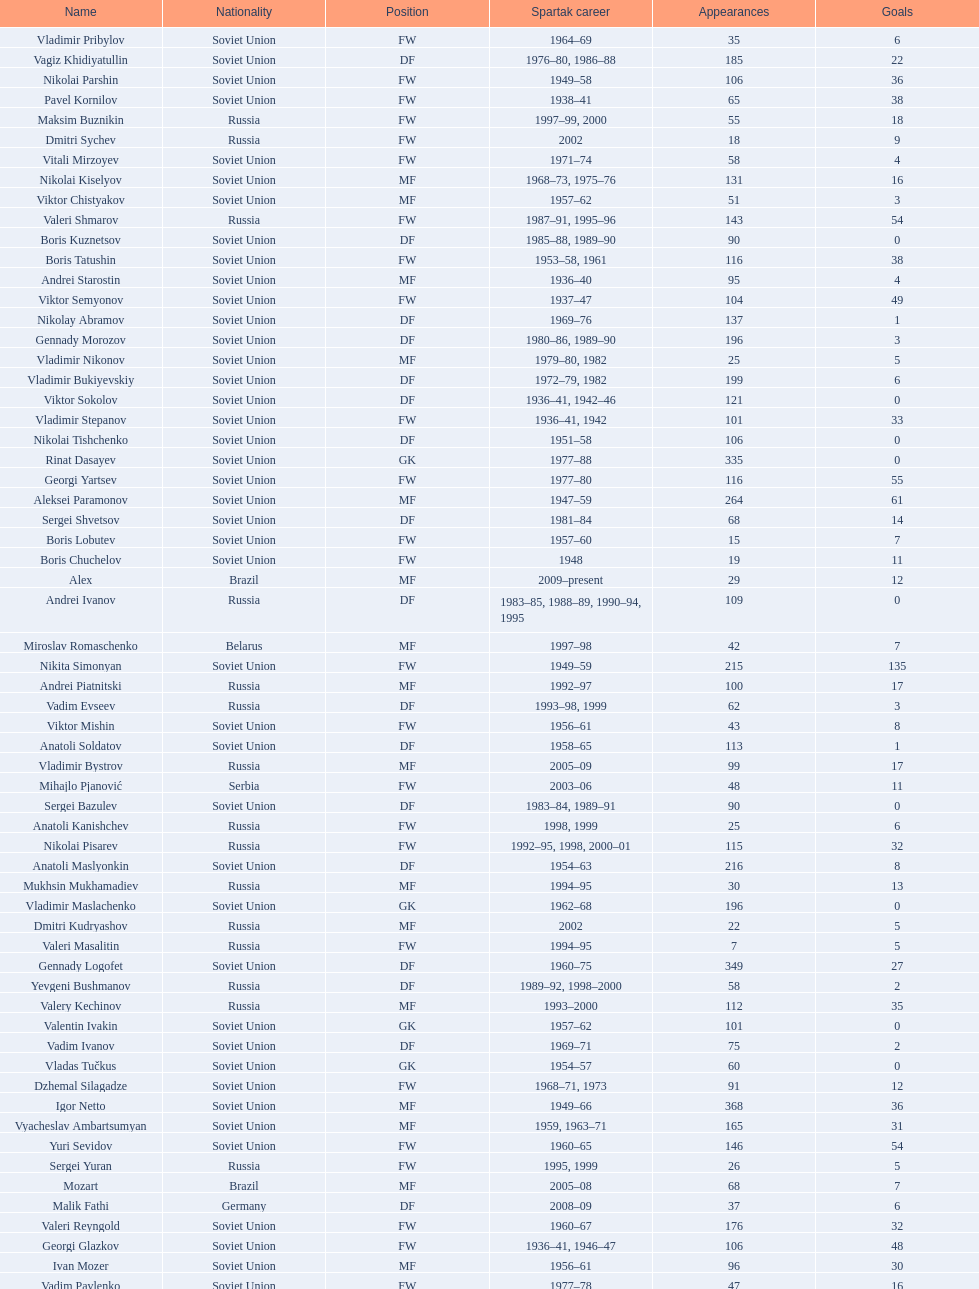Which player has the highest number of goals? Nikita Simonyan. 